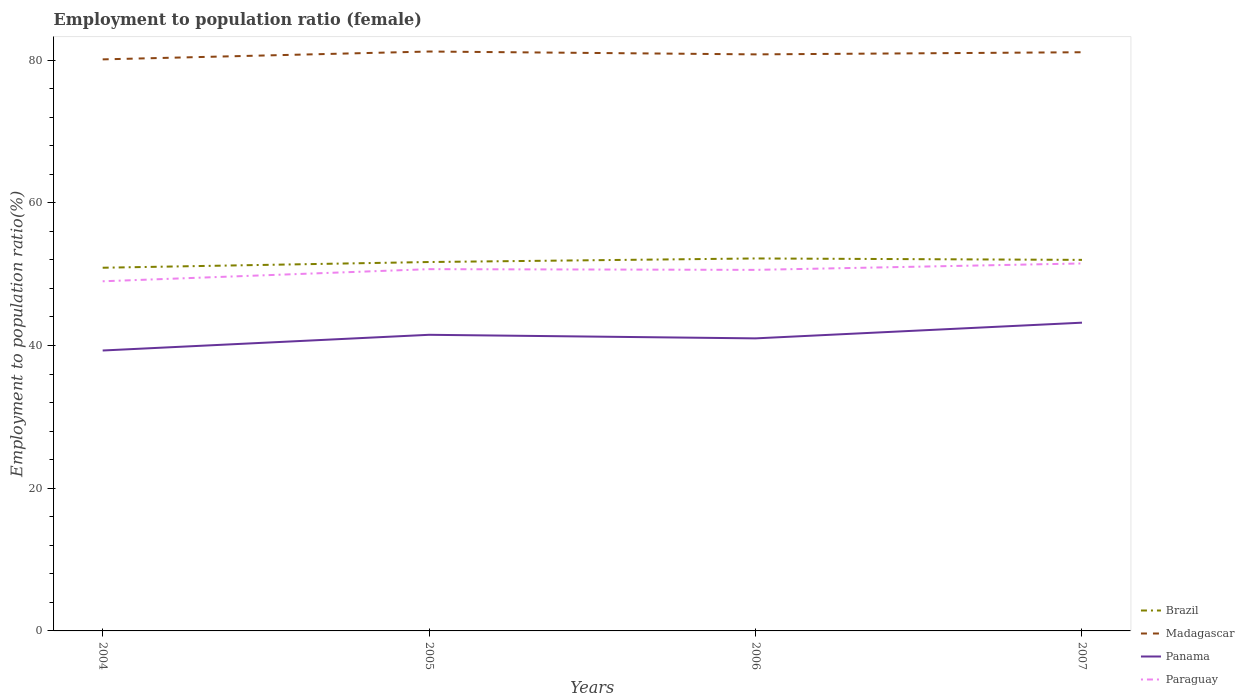Does the line corresponding to Madagascar intersect with the line corresponding to Paraguay?
Keep it short and to the point. No. Across all years, what is the maximum employment to population ratio in Panama?
Provide a succinct answer. 39.3. In which year was the employment to population ratio in Panama maximum?
Give a very brief answer. 2004. What is the total employment to population ratio in Paraguay in the graph?
Provide a succinct answer. -0.8. What is the difference between the highest and the second highest employment to population ratio in Paraguay?
Offer a very short reply. 2.5. How many lines are there?
Your response must be concise. 4. What is the difference between two consecutive major ticks on the Y-axis?
Give a very brief answer. 20. Are the values on the major ticks of Y-axis written in scientific E-notation?
Offer a terse response. No. What is the title of the graph?
Give a very brief answer. Employment to population ratio (female). Does "Kuwait" appear as one of the legend labels in the graph?
Your response must be concise. No. What is the label or title of the Y-axis?
Make the answer very short. Employment to population ratio(%). What is the Employment to population ratio(%) in Brazil in 2004?
Provide a short and direct response. 50.9. What is the Employment to population ratio(%) in Madagascar in 2004?
Your answer should be very brief. 80.1. What is the Employment to population ratio(%) of Panama in 2004?
Make the answer very short. 39.3. What is the Employment to population ratio(%) in Brazil in 2005?
Keep it short and to the point. 51.7. What is the Employment to population ratio(%) of Madagascar in 2005?
Offer a very short reply. 81.2. What is the Employment to population ratio(%) in Panama in 2005?
Give a very brief answer. 41.5. What is the Employment to population ratio(%) of Paraguay in 2005?
Provide a short and direct response. 50.7. What is the Employment to population ratio(%) in Brazil in 2006?
Your answer should be compact. 52.2. What is the Employment to population ratio(%) in Madagascar in 2006?
Offer a terse response. 80.8. What is the Employment to population ratio(%) of Paraguay in 2006?
Your answer should be very brief. 50.6. What is the Employment to population ratio(%) in Brazil in 2007?
Provide a succinct answer. 52. What is the Employment to population ratio(%) of Madagascar in 2007?
Ensure brevity in your answer.  81.1. What is the Employment to population ratio(%) of Panama in 2007?
Your answer should be compact. 43.2. What is the Employment to population ratio(%) in Paraguay in 2007?
Offer a very short reply. 51.5. Across all years, what is the maximum Employment to population ratio(%) in Brazil?
Offer a very short reply. 52.2. Across all years, what is the maximum Employment to population ratio(%) of Madagascar?
Your answer should be very brief. 81.2. Across all years, what is the maximum Employment to population ratio(%) in Panama?
Keep it short and to the point. 43.2. Across all years, what is the maximum Employment to population ratio(%) in Paraguay?
Provide a succinct answer. 51.5. Across all years, what is the minimum Employment to population ratio(%) of Brazil?
Offer a terse response. 50.9. Across all years, what is the minimum Employment to population ratio(%) of Madagascar?
Provide a short and direct response. 80.1. Across all years, what is the minimum Employment to population ratio(%) in Panama?
Give a very brief answer. 39.3. What is the total Employment to population ratio(%) in Brazil in the graph?
Make the answer very short. 206.8. What is the total Employment to population ratio(%) in Madagascar in the graph?
Your response must be concise. 323.2. What is the total Employment to population ratio(%) in Panama in the graph?
Ensure brevity in your answer.  165. What is the total Employment to population ratio(%) of Paraguay in the graph?
Offer a very short reply. 201.8. What is the difference between the Employment to population ratio(%) in Paraguay in 2004 and that in 2005?
Your response must be concise. -1.7. What is the difference between the Employment to population ratio(%) of Brazil in 2004 and that in 2006?
Offer a very short reply. -1.3. What is the difference between the Employment to population ratio(%) of Madagascar in 2004 and that in 2007?
Your answer should be very brief. -1. What is the difference between the Employment to population ratio(%) of Panama in 2004 and that in 2007?
Make the answer very short. -3.9. What is the difference between the Employment to population ratio(%) in Paraguay in 2005 and that in 2006?
Your response must be concise. 0.1. What is the difference between the Employment to population ratio(%) in Brazil in 2005 and that in 2007?
Offer a terse response. -0.3. What is the difference between the Employment to population ratio(%) of Panama in 2005 and that in 2007?
Make the answer very short. -1.7. What is the difference between the Employment to population ratio(%) in Paraguay in 2005 and that in 2007?
Make the answer very short. -0.8. What is the difference between the Employment to population ratio(%) in Madagascar in 2006 and that in 2007?
Offer a terse response. -0.3. What is the difference between the Employment to population ratio(%) in Panama in 2006 and that in 2007?
Your answer should be compact. -2.2. What is the difference between the Employment to population ratio(%) of Paraguay in 2006 and that in 2007?
Keep it short and to the point. -0.9. What is the difference between the Employment to population ratio(%) of Brazil in 2004 and the Employment to population ratio(%) of Madagascar in 2005?
Give a very brief answer. -30.3. What is the difference between the Employment to population ratio(%) in Brazil in 2004 and the Employment to population ratio(%) in Panama in 2005?
Keep it short and to the point. 9.4. What is the difference between the Employment to population ratio(%) in Brazil in 2004 and the Employment to population ratio(%) in Paraguay in 2005?
Give a very brief answer. 0.2. What is the difference between the Employment to population ratio(%) in Madagascar in 2004 and the Employment to population ratio(%) in Panama in 2005?
Make the answer very short. 38.6. What is the difference between the Employment to population ratio(%) in Madagascar in 2004 and the Employment to population ratio(%) in Paraguay in 2005?
Offer a very short reply. 29.4. What is the difference between the Employment to population ratio(%) of Brazil in 2004 and the Employment to population ratio(%) of Madagascar in 2006?
Your answer should be compact. -29.9. What is the difference between the Employment to population ratio(%) in Brazil in 2004 and the Employment to population ratio(%) in Panama in 2006?
Offer a very short reply. 9.9. What is the difference between the Employment to population ratio(%) in Madagascar in 2004 and the Employment to population ratio(%) in Panama in 2006?
Your response must be concise. 39.1. What is the difference between the Employment to population ratio(%) of Madagascar in 2004 and the Employment to population ratio(%) of Paraguay in 2006?
Offer a terse response. 29.5. What is the difference between the Employment to population ratio(%) of Brazil in 2004 and the Employment to population ratio(%) of Madagascar in 2007?
Make the answer very short. -30.2. What is the difference between the Employment to population ratio(%) of Madagascar in 2004 and the Employment to population ratio(%) of Panama in 2007?
Offer a very short reply. 36.9. What is the difference between the Employment to population ratio(%) of Madagascar in 2004 and the Employment to population ratio(%) of Paraguay in 2007?
Provide a succinct answer. 28.6. What is the difference between the Employment to population ratio(%) in Panama in 2004 and the Employment to population ratio(%) in Paraguay in 2007?
Make the answer very short. -12.2. What is the difference between the Employment to population ratio(%) in Brazil in 2005 and the Employment to population ratio(%) in Madagascar in 2006?
Provide a short and direct response. -29.1. What is the difference between the Employment to population ratio(%) of Brazil in 2005 and the Employment to population ratio(%) of Panama in 2006?
Provide a succinct answer. 10.7. What is the difference between the Employment to population ratio(%) of Brazil in 2005 and the Employment to population ratio(%) of Paraguay in 2006?
Offer a very short reply. 1.1. What is the difference between the Employment to population ratio(%) in Madagascar in 2005 and the Employment to population ratio(%) in Panama in 2006?
Offer a terse response. 40.2. What is the difference between the Employment to population ratio(%) of Madagascar in 2005 and the Employment to population ratio(%) of Paraguay in 2006?
Give a very brief answer. 30.6. What is the difference between the Employment to population ratio(%) of Brazil in 2005 and the Employment to population ratio(%) of Madagascar in 2007?
Offer a very short reply. -29.4. What is the difference between the Employment to population ratio(%) of Madagascar in 2005 and the Employment to population ratio(%) of Paraguay in 2007?
Make the answer very short. 29.7. What is the difference between the Employment to population ratio(%) of Brazil in 2006 and the Employment to population ratio(%) of Madagascar in 2007?
Your answer should be very brief. -28.9. What is the difference between the Employment to population ratio(%) in Brazil in 2006 and the Employment to population ratio(%) in Panama in 2007?
Provide a succinct answer. 9. What is the difference between the Employment to population ratio(%) of Madagascar in 2006 and the Employment to population ratio(%) of Panama in 2007?
Offer a terse response. 37.6. What is the difference between the Employment to population ratio(%) in Madagascar in 2006 and the Employment to population ratio(%) in Paraguay in 2007?
Give a very brief answer. 29.3. What is the difference between the Employment to population ratio(%) of Panama in 2006 and the Employment to population ratio(%) of Paraguay in 2007?
Your answer should be very brief. -10.5. What is the average Employment to population ratio(%) in Brazil per year?
Your response must be concise. 51.7. What is the average Employment to population ratio(%) of Madagascar per year?
Your answer should be compact. 80.8. What is the average Employment to population ratio(%) of Panama per year?
Make the answer very short. 41.25. What is the average Employment to population ratio(%) of Paraguay per year?
Offer a very short reply. 50.45. In the year 2004, what is the difference between the Employment to population ratio(%) of Brazil and Employment to population ratio(%) of Madagascar?
Keep it short and to the point. -29.2. In the year 2004, what is the difference between the Employment to population ratio(%) of Madagascar and Employment to population ratio(%) of Panama?
Ensure brevity in your answer.  40.8. In the year 2004, what is the difference between the Employment to population ratio(%) of Madagascar and Employment to population ratio(%) of Paraguay?
Your response must be concise. 31.1. In the year 2005, what is the difference between the Employment to population ratio(%) in Brazil and Employment to population ratio(%) in Madagascar?
Give a very brief answer. -29.5. In the year 2005, what is the difference between the Employment to population ratio(%) in Brazil and Employment to population ratio(%) in Panama?
Your answer should be very brief. 10.2. In the year 2005, what is the difference between the Employment to population ratio(%) in Madagascar and Employment to population ratio(%) in Panama?
Make the answer very short. 39.7. In the year 2005, what is the difference between the Employment to population ratio(%) in Madagascar and Employment to population ratio(%) in Paraguay?
Give a very brief answer. 30.5. In the year 2006, what is the difference between the Employment to population ratio(%) of Brazil and Employment to population ratio(%) of Madagascar?
Provide a succinct answer. -28.6. In the year 2006, what is the difference between the Employment to population ratio(%) in Brazil and Employment to population ratio(%) in Panama?
Ensure brevity in your answer.  11.2. In the year 2006, what is the difference between the Employment to population ratio(%) of Brazil and Employment to population ratio(%) of Paraguay?
Your answer should be compact. 1.6. In the year 2006, what is the difference between the Employment to population ratio(%) of Madagascar and Employment to population ratio(%) of Panama?
Provide a short and direct response. 39.8. In the year 2006, what is the difference between the Employment to population ratio(%) of Madagascar and Employment to population ratio(%) of Paraguay?
Keep it short and to the point. 30.2. In the year 2006, what is the difference between the Employment to population ratio(%) in Panama and Employment to population ratio(%) in Paraguay?
Your response must be concise. -9.6. In the year 2007, what is the difference between the Employment to population ratio(%) of Brazil and Employment to population ratio(%) of Madagascar?
Provide a succinct answer. -29.1. In the year 2007, what is the difference between the Employment to population ratio(%) of Brazil and Employment to population ratio(%) of Panama?
Your response must be concise. 8.8. In the year 2007, what is the difference between the Employment to population ratio(%) of Brazil and Employment to population ratio(%) of Paraguay?
Your response must be concise. 0.5. In the year 2007, what is the difference between the Employment to population ratio(%) of Madagascar and Employment to population ratio(%) of Panama?
Offer a very short reply. 37.9. In the year 2007, what is the difference between the Employment to population ratio(%) of Madagascar and Employment to population ratio(%) of Paraguay?
Your answer should be very brief. 29.6. In the year 2007, what is the difference between the Employment to population ratio(%) of Panama and Employment to population ratio(%) of Paraguay?
Offer a very short reply. -8.3. What is the ratio of the Employment to population ratio(%) of Brazil in 2004 to that in 2005?
Keep it short and to the point. 0.98. What is the ratio of the Employment to population ratio(%) of Madagascar in 2004 to that in 2005?
Your response must be concise. 0.99. What is the ratio of the Employment to population ratio(%) of Panama in 2004 to that in 2005?
Provide a succinct answer. 0.95. What is the ratio of the Employment to population ratio(%) of Paraguay in 2004 to that in 2005?
Provide a short and direct response. 0.97. What is the ratio of the Employment to population ratio(%) in Brazil in 2004 to that in 2006?
Provide a short and direct response. 0.98. What is the ratio of the Employment to population ratio(%) in Panama in 2004 to that in 2006?
Make the answer very short. 0.96. What is the ratio of the Employment to population ratio(%) in Paraguay in 2004 to that in 2006?
Offer a very short reply. 0.97. What is the ratio of the Employment to population ratio(%) of Brazil in 2004 to that in 2007?
Provide a short and direct response. 0.98. What is the ratio of the Employment to population ratio(%) in Madagascar in 2004 to that in 2007?
Make the answer very short. 0.99. What is the ratio of the Employment to population ratio(%) of Panama in 2004 to that in 2007?
Your answer should be very brief. 0.91. What is the ratio of the Employment to population ratio(%) of Paraguay in 2004 to that in 2007?
Your response must be concise. 0.95. What is the ratio of the Employment to population ratio(%) in Madagascar in 2005 to that in 2006?
Provide a short and direct response. 1. What is the ratio of the Employment to population ratio(%) in Panama in 2005 to that in 2006?
Ensure brevity in your answer.  1.01. What is the ratio of the Employment to population ratio(%) in Madagascar in 2005 to that in 2007?
Give a very brief answer. 1. What is the ratio of the Employment to population ratio(%) of Panama in 2005 to that in 2007?
Offer a very short reply. 0.96. What is the ratio of the Employment to population ratio(%) in Paraguay in 2005 to that in 2007?
Offer a very short reply. 0.98. What is the ratio of the Employment to population ratio(%) in Madagascar in 2006 to that in 2007?
Keep it short and to the point. 1. What is the ratio of the Employment to population ratio(%) of Panama in 2006 to that in 2007?
Your response must be concise. 0.95. What is the ratio of the Employment to population ratio(%) of Paraguay in 2006 to that in 2007?
Your response must be concise. 0.98. What is the difference between the highest and the second highest Employment to population ratio(%) in Brazil?
Give a very brief answer. 0.2. What is the difference between the highest and the second highest Employment to population ratio(%) of Madagascar?
Ensure brevity in your answer.  0.1. What is the difference between the highest and the second highest Employment to population ratio(%) of Paraguay?
Your response must be concise. 0.8. What is the difference between the highest and the lowest Employment to population ratio(%) in Brazil?
Give a very brief answer. 1.3. What is the difference between the highest and the lowest Employment to population ratio(%) in Panama?
Offer a very short reply. 3.9. 